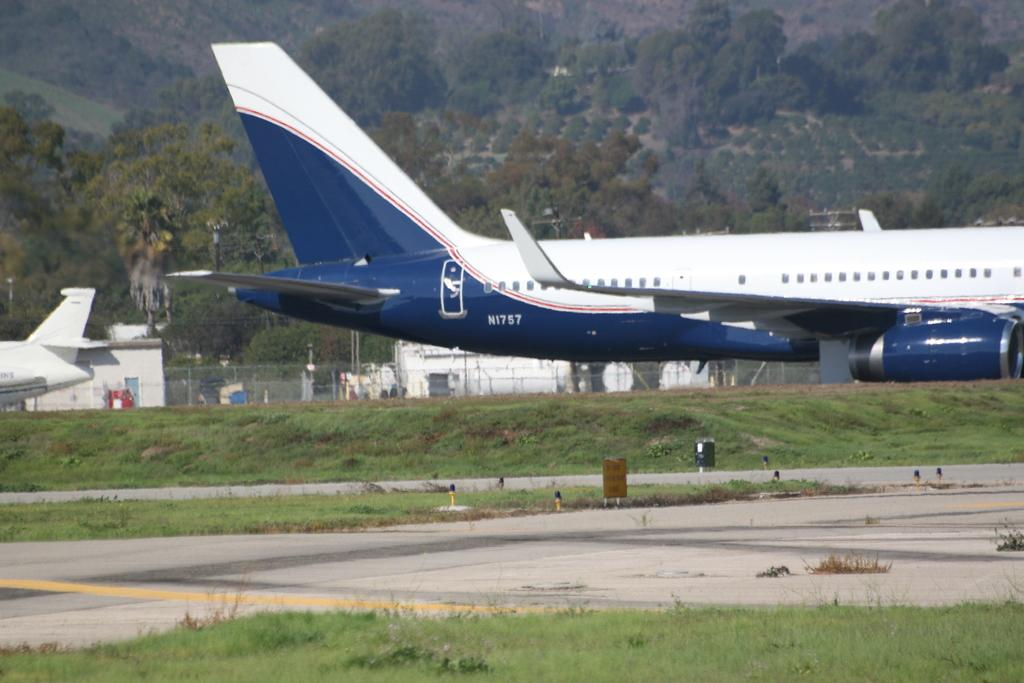<image>
Render a clear and concise summary of the photo. Airplane with the plate "N1757" is parked on the runway. 